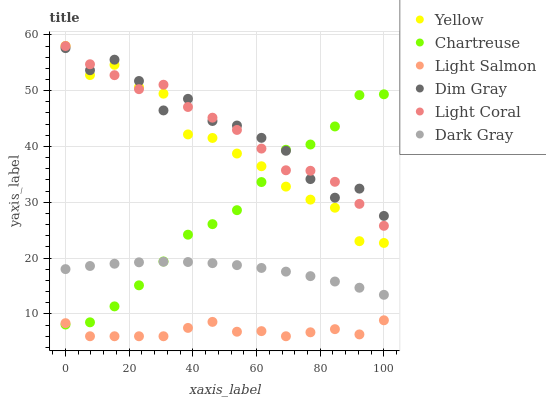Does Light Salmon have the minimum area under the curve?
Answer yes or no. Yes. Does Dim Gray have the maximum area under the curve?
Answer yes or no. Yes. Does Dim Gray have the minimum area under the curve?
Answer yes or no. No. Does Light Salmon have the maximum area under the curve?
Answer yes or no. No. Is Dark Gray the smoothest?
Answer yes or no. Yes. Is Dim Gray the roughest?
Answer yes or no. Yes. Is Light Salmon the smoothest?
Answer yes or no. No. Is Light Salmon the roughest?
Answer yes or no. No. Does Light Salmon have the lowest value?
Answer yes or no. Yes. Does Dim Gray have the lowest value?
Answer yes or no. No. Does Light Coral have the highest value?
Answer yes or no. Yes. Does Dim Gray have the highest value?
Answer yes or no. No. Is Light Salmon less than Light Coral?
Answer yes or no. Yes. Is Dim Gray greater than Light Salmon?
Answer yes or no. Yes. Does Light Salmon intersect Chartreuse?
Answer yes or no. Yes. Is Light Salmon less than Chartreuse?
Answer yes or no. No. Is Light Salmon greater than Chartreuse?
Answer yes or no. No. Does Light Salmon intersect Light Coral?
Answer yes or no. No. 